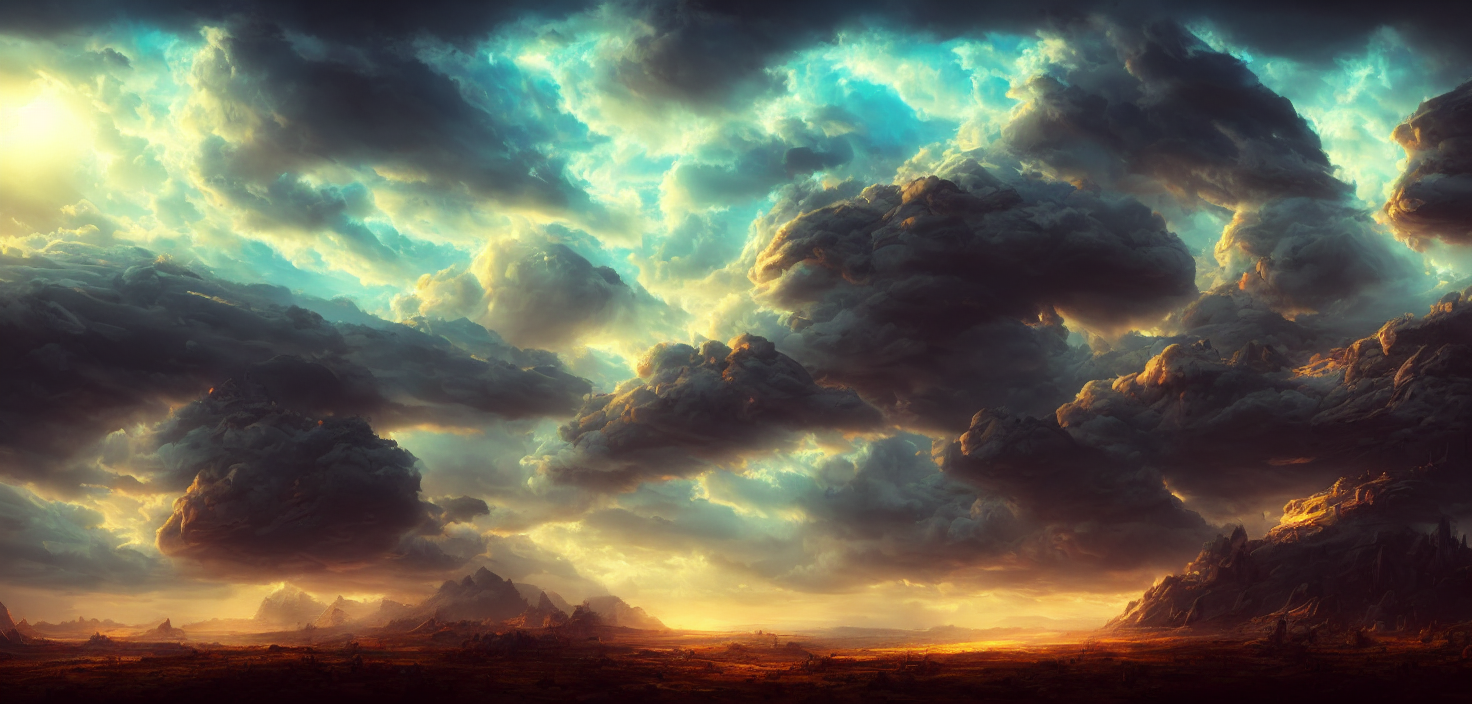What is the overall clarity of the image?
A. Excellent
B. Relatively average
C. Poor
Answer with the option's letter from the given choices directly. The overall clarity of the image is relatively average. While the foreground and midground are depicted with sharp details and crisp textures, there is a softening of focus that becomes more pronounced as our view extends towards the background, giving the distant mountains and some parts of the clouds a slight haze. This effect contributes to the image's depth and atmospheric perspective, ultimately presenting a visually cohesive and balanced scene. 